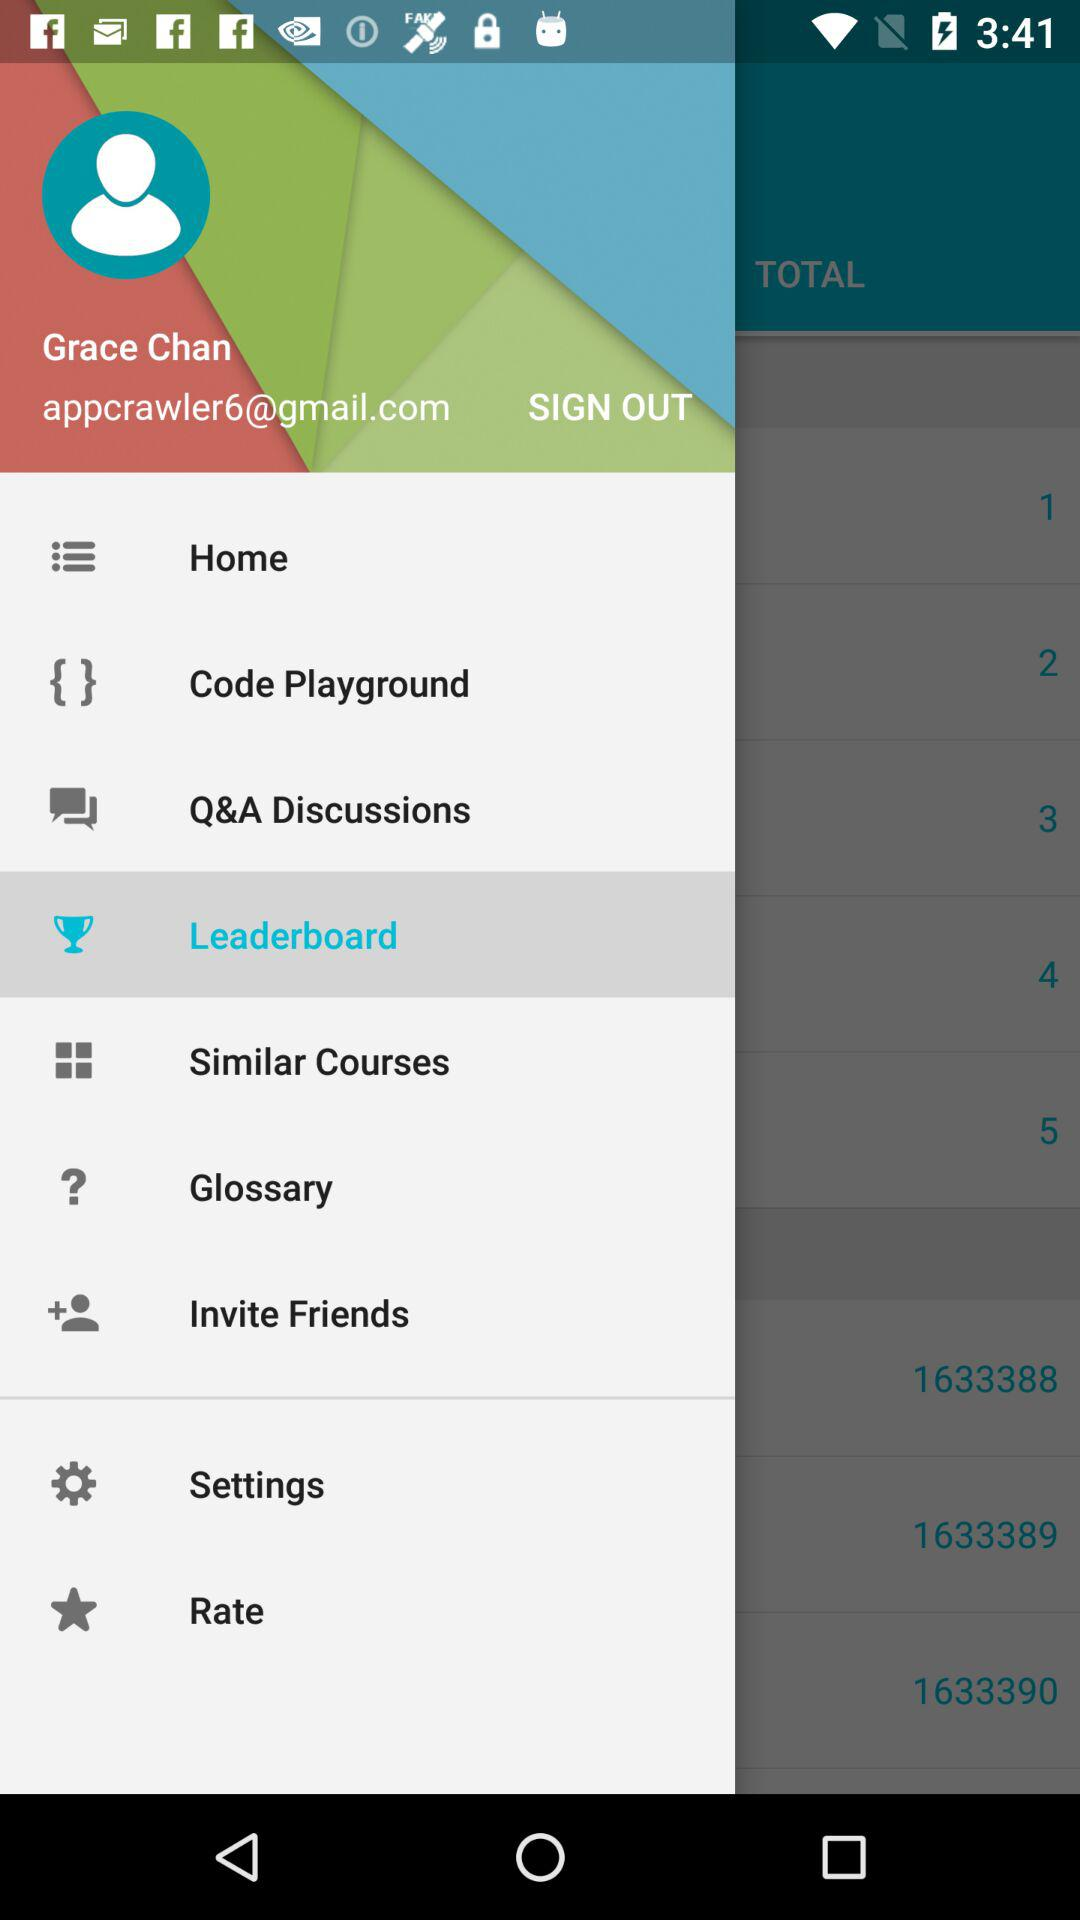What is the name of the user? The name of the user is Grace Chan. 